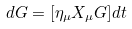<formula> <loc_0><loc_0><loc_500><loc_500>d G = [ \eta _ { \mu } X _ { \mu } G ] d t</formula> 